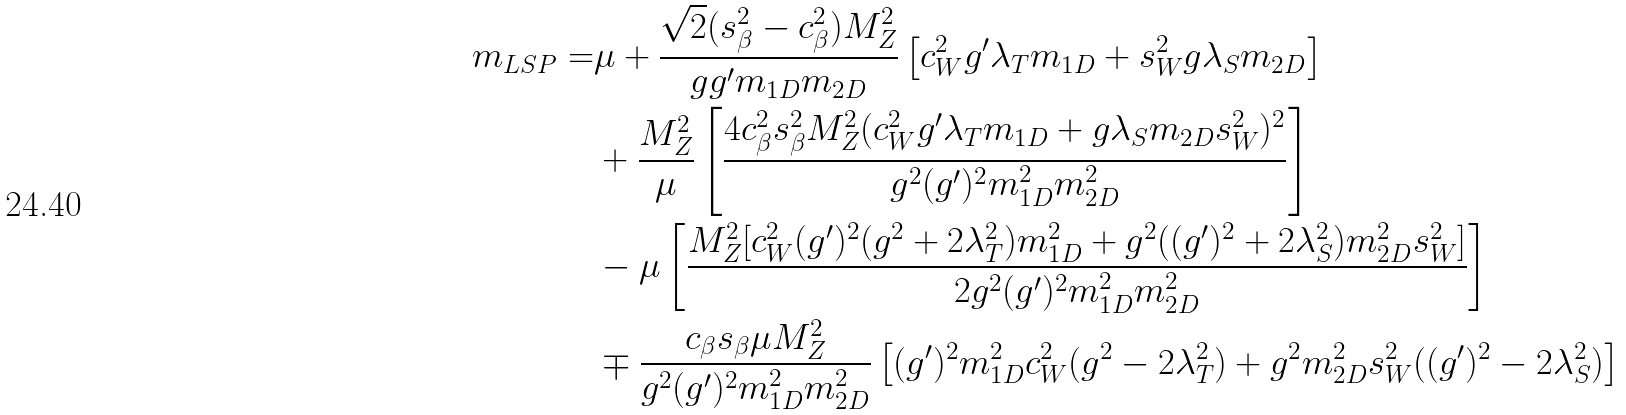<formula> <loc_0><loc_0><loc_500><loc_500>m _ { L S P } = & \mu + \frac { \sqrt { 2 } ( s _ { \beta } ^ { 2 } - c _ { \beta } ^ { 2 } ) M _ { Z } ^ { 2 } } { g g ^ { \prime } m _ { 1 D } m _ { 2 D } } \left [ c _ { W } ^ { 2 } g ^ { \prime } \lambda _ { T } m _ { 1 D } + s _ { W } ^ { 2 } g \lambda _ { S } m _ { 2 D } \right ] \\ & + \frac { M _ { Z } ^ { 2 } } { \mu } \left [ \frac { 4 c _ { \beta } ^ { 2 } s _ { \beta } ^ { 2 } M _ { Z } ^ { 2 } ( c _ { W } ^ { 2 } g ^ { \prime } \lambda _ { T } m _ { 1 D } + g \lambda _ { S } m _ { 2 D } s _ { W } ^ { 2 } ) ^ { 2 } } { g ^ { 2 } ( g ^ { \prime } ) ^ { 2 } m _ { 1 D } ^ { 2 } m _ { 2 D } ^ { 2 } } \right ] \\ & - \mu \left [ \frac { M _ { Z } ^ { 2 } [ c _ { W } ^ { 2 } ( g ^ { \prime } ) ^ { 2 } ( g ^ { 2 } + 2 \lambda _ { T } ^ { 2 } ) m _ { 1 D } ^ { 2 } + g ^ { 2 } ( ( g ^ { \prime } ) ^ { 2 } + 2 \lambda _ { S } ^ { 2 } ) m _ { 2 D } ^ { 2 } s _ { W } ^ { 2 } ] } { 2 g ^ { 2 } ( g ^ { \prime } ) ^ { 2 } m _ { 1 D } ^ { 2 } m _ { 2 D } ^ { 2 } } \right ] \\ & \mp \frac { c _ { \beta } s _ { \beta } \mu M _ { Z } ^ { 2 } } { g ^ { 2 } ( g ^ { \prime } ) ^ { 2 } m _ { 1 D } ^ { 2 } m _ { 2 D } ^ { 2 } } \left [ ( g ^ { \prime } ) ^ { 2 } m _ { 1 D } ^ { 2 } c _ { W } ^ { 2 } ( g ^ { 2 } - 2 \lambda _ { T } ^ { 2 } ) + g ^ { 2 } m _ { 2 D } ^ { 2 } s _ { W } ^ { 2 } ( ( g ^ { \prime } ) ^ { 2 } - 2 \lambda _ { S } ^ { 2 } ) \right ]</formula> 